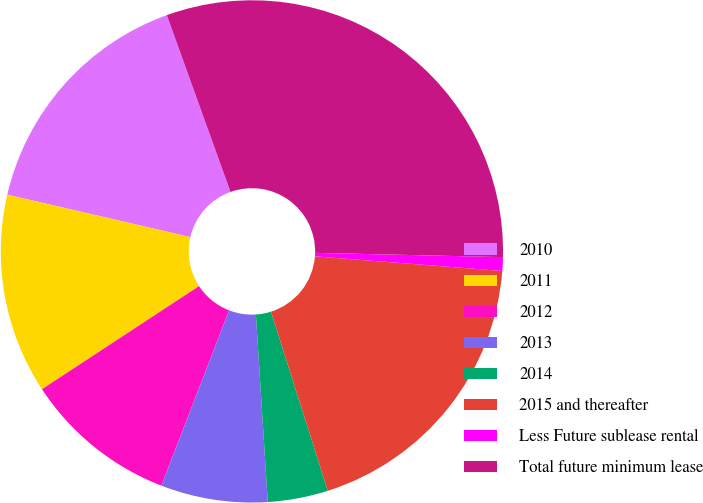Convert chart. <chart><loc_0><loc_0><loc_500><loc_500><pie_chart><fcel>2010<fcel>2011<fcel>2012<fcel>2013<fcel>2014<fcel>2015 and thereafter<fcel>Less Future sublease rental<fcel>Total future minimum lease<nl><fcel>15.87%<fcel>12.87%<fcel>9.88%<fcel>6.88%<fcel>3.88%<fcel>18.87%<fcel>0.88%<fcel>30.86%<nl></chart> 